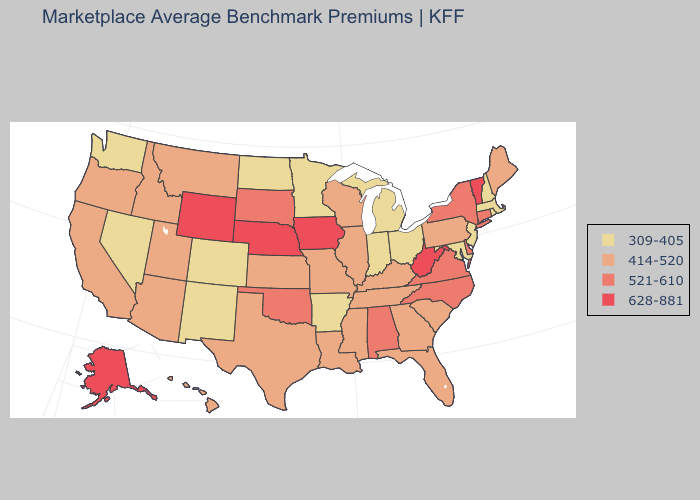What is the highest value in the MidWest ?
Concise answer only. 628-881. Which states have the lowest value in the USA?
Concise answer only. Arkansas, Colorado, Indiana, Maryland, Massachusetts, Michigan, Minnesota, Nevada, New Hampshire, New Jersey, New Mexico, North Dakota, Ohio, Rhode Island, Washington. Name the states that have a value in the range 414-520?
Be succinct. Arizona, California, Florida, Georgia, Hawaii, Idaho, Illinois, Kansas, Kentucky, Louisiana, Maine, Mississippi, Missouri, Montana, Oregon, Pennsylvania, South Carolina, Tennessee, Texas, Utah, Wisconsin. Among the states that border Minnesota , does South Dakota have the lowest value?
Keep it brief. No. Name the states that have a value in the range 628-881?
Quick response, please. Alaska, Iowa, Nebraska, Vermont, West Virginia, Wyoming. Which states have the lowest value in the USA?
Short answer required. Arkansas, Colorado, Indiana, Maryland, Massachusetts, Michigan, Minnesota, Nevada, New Hampshire, New Jersey, New Mexico, North Dakota, Ohio, Rhode Island, Washington. Name the states that have a value in the range 628-881?
Be succinct. Alaska, Iowa, Nebraska, Vermont, West Virginia, Wyoming. Name the states that have a value in the range 414-520?
Short answer required. Arizona, California, Florida, Georgia, Hawaii, Idaho, Illinois, Kansas, Kentucky, Louisiana, Maine, Mississippi, Missouri, Montana, Oregon, Pennsylvania, South Carolina, Tennessee, Texas, Utah, Wisconsin. Among the states that border Virginia , which have the highest value?
Short answer required. West Virginia. Does the map have missing data?
Concise answer only. No. Among the states that border Ohio , does Kentucky have the highest value?
Write a very short answer. No. Which states hav the highest value in the Northeast?
Give a very brief answer. Vermont. How many symbols are there in the legend?
Answer briefly. 4. Which states have the highest value in the USA?
Keep it brief. Alaska, Iowa, Nebraska, Vermont, West Virginia, Wyoming. Does the first symbol in the legend represent the smallest category?
Write a very short answer. Yes. 